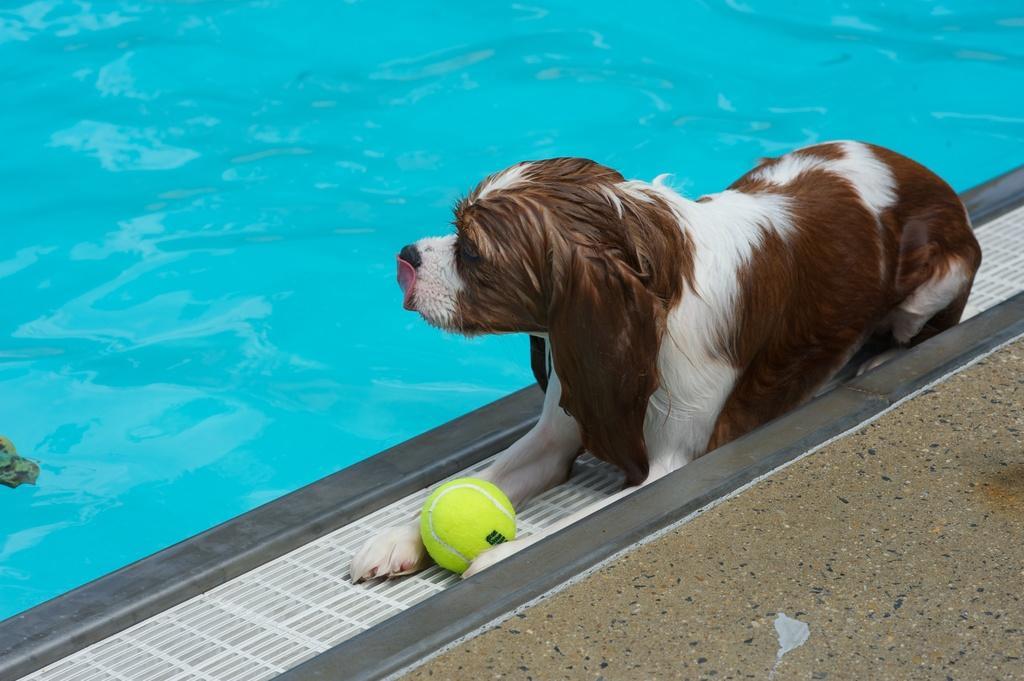How would you summarize this image in a sentence or two? In the foreground of this image, there is a dog, a ball and the floor. At the top, there is swimming pool water. 